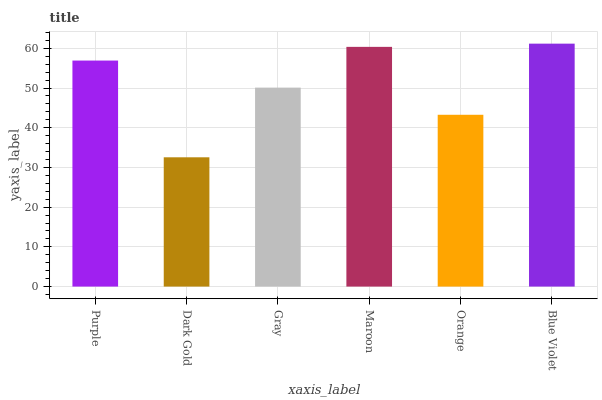Is Gray the minimum?
Answer yes or no. No. Is Gray the maximum?
Answer yes or no. No. Is Gray greater than Dark Gold?
Answer yes or no. Yes. Is Dark Gold less than Gray?
Answer yes or no. Yes. Is Dark Gold greater than Gray?
Answer yes or no. No. Is Gray less than Dark Gold?
Answer yes or no. No. Is Purple the high median?
Answer yes or no. Yes. Is Gray the low median?
Answer yes or no. Yes. Is Dark Gold the high median?
Answer yes or no. No. Is Purple the low median?
Answer yes or no. No. 